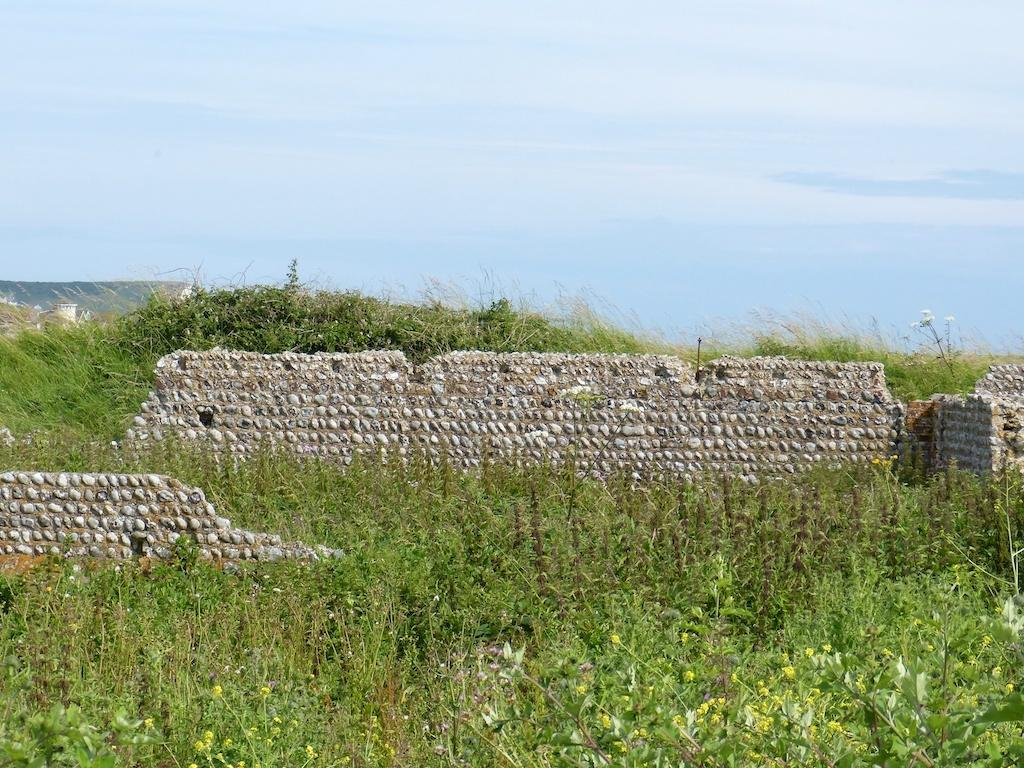What type of living organisms can be seen in the image? Plants can be seen in the image. What type of structures are present in the image? There are walls in the image. What is visible in the background of the image? The sky is visible in the image. What can be seen in the sky? Clouds are present in the sky. What type of fowl is reciting a verse in the image? There is no fowl or verse present in the image. What type of vessel is being used to transport the plants in the image? There is no vessel present in the image; the plants are stationary. 